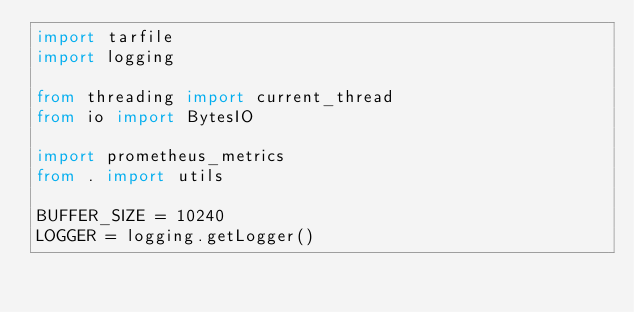<code> <loc_0><loc_0><loc_500><loc_500><_Python_>import tarfile
import logging

from threading import current_thread
from io import BytesIO

import prometheus_metrics
from . import utils

BUFFER_SIZE = 10240
LOGGER = logging.getLogger()

</code> 